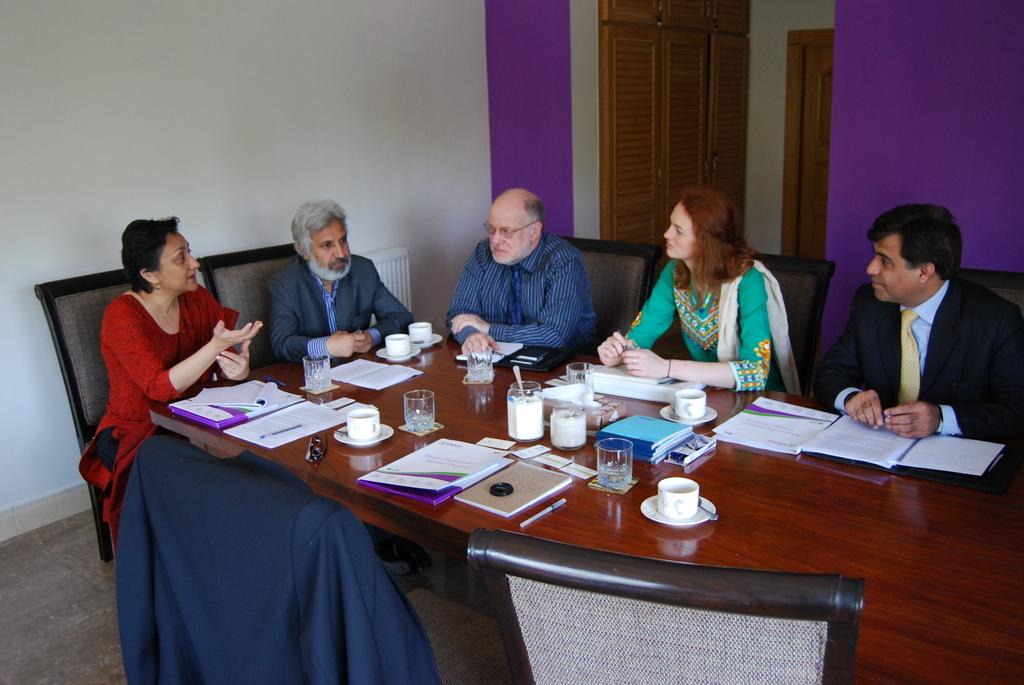What are the people in the image doing? There is a group of people sitting in chairs. What is in front of the group of people? There is a table in front of the group of people. What items can be seen on the table? The table consists of a cup, glass, book, and pen. What colors are present on the background wall? The background wall is white and violet in color. What is the name of the theory that the people in the image are discussing? A: There is no indication in the image that the people are discussing a theory, so it cannot be determined from the picture. 